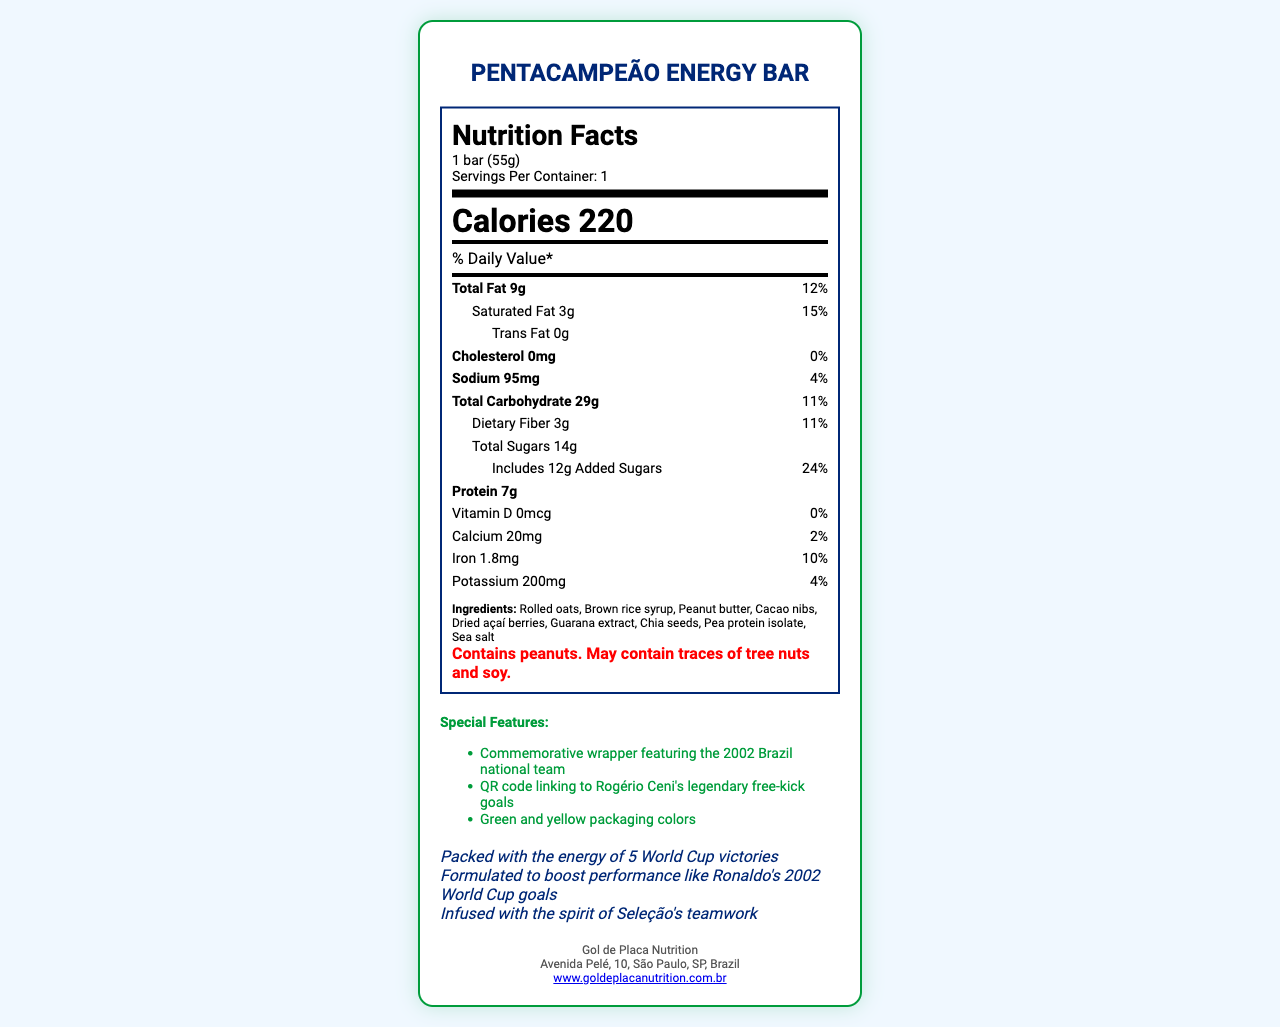what is the serving size of the Pentacampeão Energy Bar? The document lists the serving size as "1 bar (55g)" in the nutrition label.
Answer: 1 bar (55g) how many calories are in one serving of the Pentacampeão Energy Bar? The nutrition label indicates that one serving of the energy bar contains 220 calories.
Answer: 220 how many grams of total fat does the Pentacampeão Energy Bar contain? The nutrition label shows that the energy bar contains 9 grams of total fat.
Answer: 9g what is the percent daily value of saturated fat in the Pentacampeão Energy Bar? The nutrition label lists the percent daily value of saturated fat as 15%.
Answer: 15% what is the amount of protein in the Pentacampeão Energy Bar? The nutrition label indicates that the energy bar contains 7 grams of protein.
Answer: 7g what are the main ingredients in the Pentacampeão Energy Bar? A. Oats, honey, nuts B. Rolled oats, brown rice syrup, peanut butter C. Rice, wheat, milk The document lists "Rolled oats, Brown rice syrup, Peanut butter" as the main ingredients in the energy bar.
Answer: B. Rolled oats, brown rice syrup, peanut butter what special feature does the QR code on the wrapper link to? A. A video of Brazil's highlights from the 2002 World Cup B. Rogério Ceni's legendary free-kick goals C. A biography of Pele The document states that one of the special features is a QR code linking to Rogério Ceni's legendary free-kick goals.
Answer: B. Rogério Ceni's legendary free-kick goals does the Pentacampeão Energy Bar contain any cholesterol? The nutrition label states that the energy bar contains 0mg of cholesterol.
Answer: No is the Pentacampeão Energy Bar suitable for someone with a peanut allergy? The allergen information clearly states that the energy bar contains peanuts.
Answer: No summarize the key features and nutritional information of the Pentacampeão Energy Bar. This summary encompasses all the key nutritional information, special features, ingredients, and allergen details of the Pentacampeão Energy Bar.
Answer: The Pentacampeão Energy Bar is a commemorative product celebrating Brazil's 2002 World Cup victory. It has a serving size of 1 bar (55g) containing 220 calories, 9g of total fat, 29g of carbohydrates, 14g of total sugars, and 7g of protein. It includes ingredients like rolled oats, brown rice syrup, peanut butter, and guarana extract. The bar does not contain cholesterol but has 95mg of sodium and 3g of dietary fiber. Special features include a commemorative wrapper, a QR code linking to Rogério Ceni's legendary free-kick goals, and green and yellow packaging. The bar contains peanuts and may have traces of tree nuts and soy. how is the energy bar marketed to fans of Brazilian football? The marketing claims include references to Brazil's World Cup victories, Ronaldo's performance, and the teamwork of the Seleção, which targets fans of Brazilian football.
Answer: Packed with the energy of 5 World Cup victories; Formulated to boost performance like Ronaldo's 2002 World Cup goals; Infused with the spirit of Seleção's teamwork where is the manufacturer of the Pentacampeão Energy Bar based? The manufacturer information indicates that "Gol de Placa Nutrition" is based at Avenida Pelé, 10, São Paulo, SP, Brazil.
Answer: São Paulo, SP, Brazil how much potassium is in the Pentacampeão Energy Bar? The nutrition label indicates that the energy bar contains 200mg of potassium.
Answer: 200mg which ingredient is not listed in the Pentacampeão Energy Bar? A. Dried açaí berries B. Guarana extract C. Vanilla extract The ingredient list includes dried açaí berries and guarana extract, but does not mention vanilla extract.
Answer: C. Vanilla extract can the exact recipe of the energy bar be determined from the document? The document lists the ingredient names but does not provide the exact proportions or detailed recipe needed to reproduce the energy bar.
Answer: No 